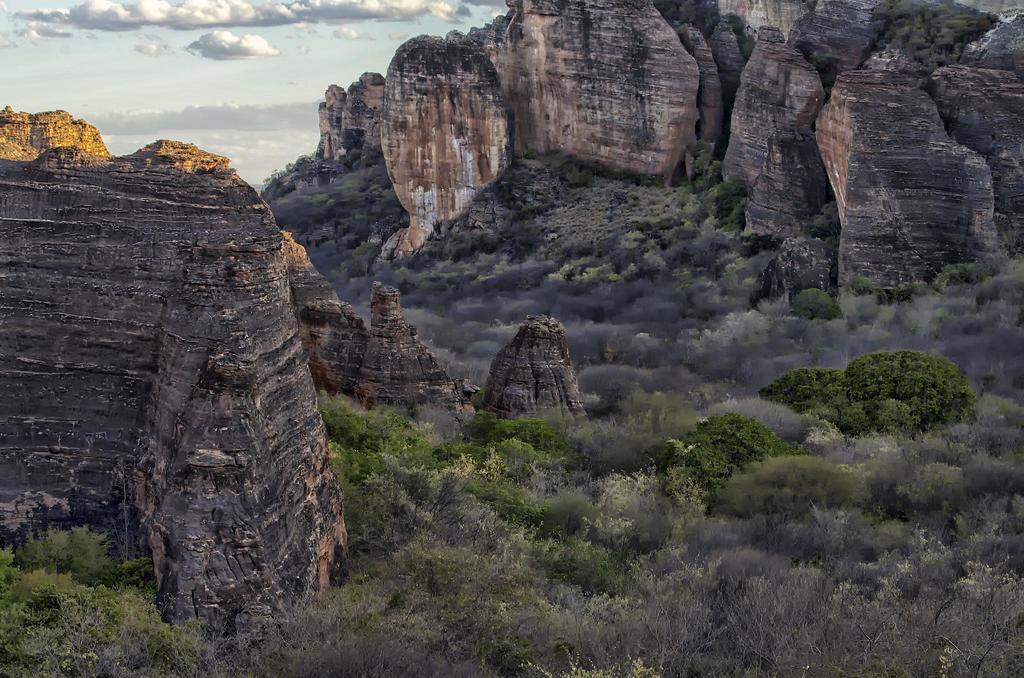What type of natural landscape is depicted in the image? The image features mountains. What other natural elements can be seen in the image? There are trees and plants on the ground visible in the image. What is visible in the sky in the image? There are clouds visible in the sky in the image. Where is the patch of grass located in the image? There is no patch of grass mentioned in the provided facts; the image only mentions mountains, trees, plants on the ground, and clouds in the sky. What type of battle is taking place in the image? There is no battle present in the image; it features a natural landscape with mountains, trees, plants on the ground, and clouds in the sky. 